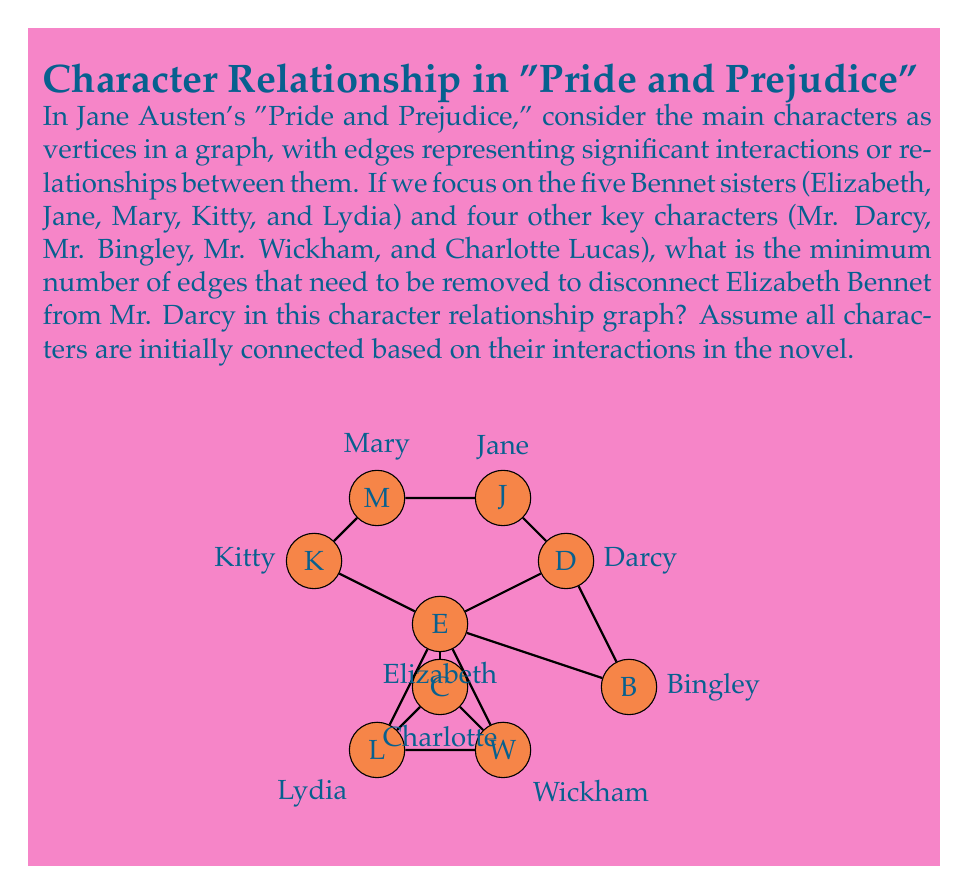Show me your answer to this math problem. To solve this problem, we need to apply the concept of edge connectivity in graph theory. The edge connectivity of a graph is the minimum number of edges that need to be removed to disconnect the graph. In this case, we're specifically looking at the edge connectivity between Elizabeth Bennet and Mr. Darcy.

Let's approach this step-by-step:

1) First, we need to identify all possible paths between Elizabeth and Mr. Darcy. In the given graph, we can see several paths:
   a) Elizabeth -- Darcy (direct connection)
   b) Elizabeth -- Jane -- Darcy
   c) Elizabeth -- Bingley -- Darcy
   d) Elizabeth -- Charlotte -- Wickham -- Lydia -- Darcy

2) The concept we need to apply here is Menger's theorem, which states that the edge connectivity between two vertices is equal to the maximum number of edge-disjoint paths between them.

3) Looking at our paths:
   - Path (a) is edge-disjoint from all others
   - Path (b) shares no edges with (a) or (c)
   - Path (c) is edge-disjoint from all others
   - Path (d) shares no edges with (a), (b), or (c)

4) Therefore, we have 4 edge-disjoint paths between Elizabeth and Darcy.

5) According to Menger's theorem, this means that the minimum number of edges that need to be removed to disconnect Elizabeth from Darcy is also 4.

6) We can verify this: if we remove the edges (Elizabeth -- Darcy), (Elizabeth -- Jane), (Elizabeth -- Bingley), and (Elizabeth -- Charlotte), there will be no remaining path between Elizabeth and Darcy.

Thus, the minimum number of edges that need to be removed to disconnect Elizabeth Bennet from Mr. Darcy is 4.
Answer: 4 